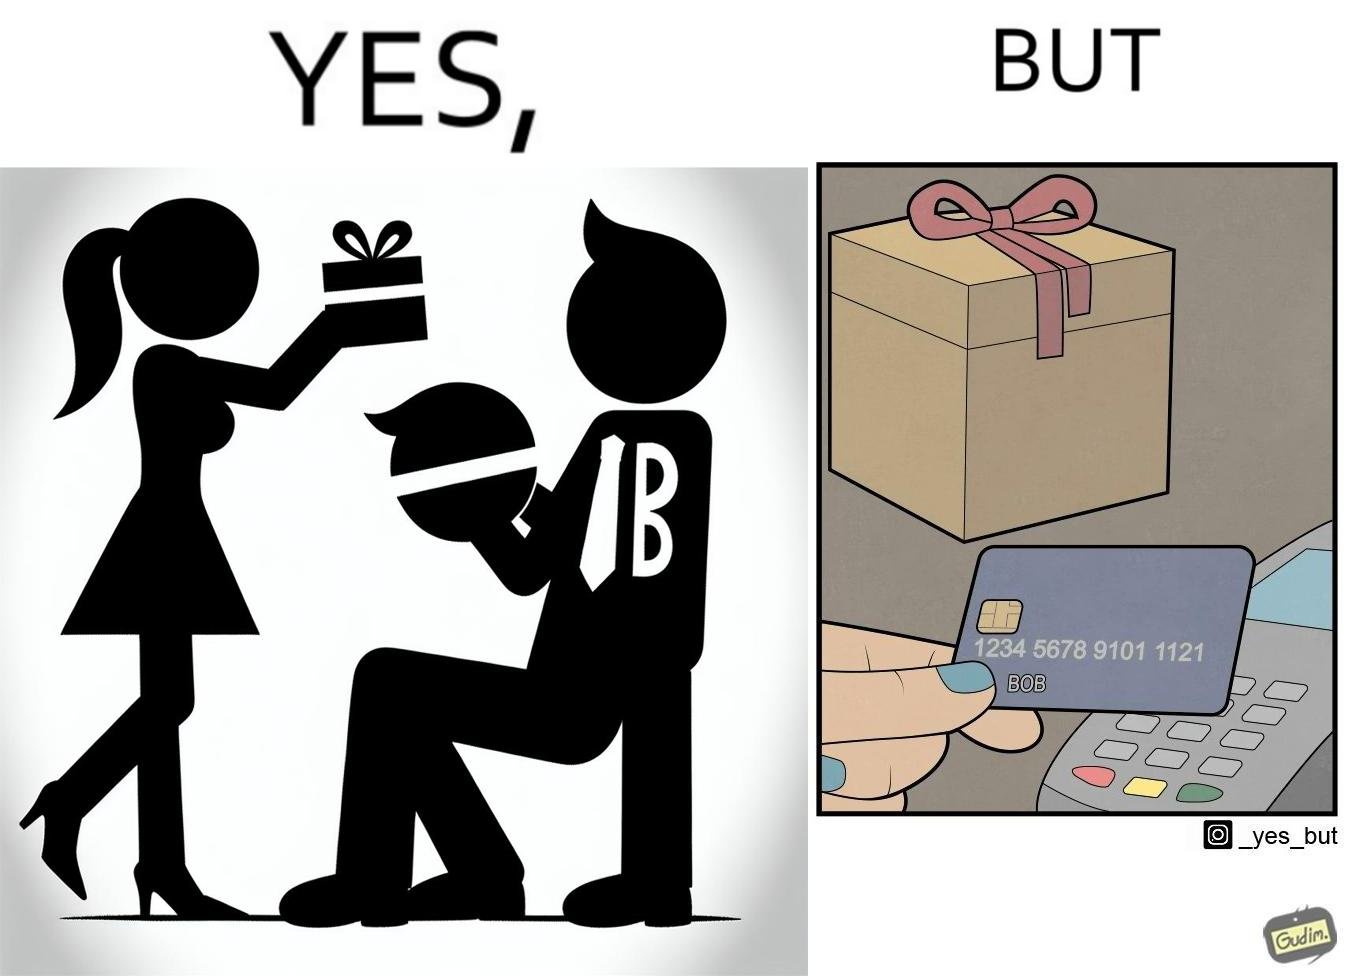Would you classify this image as satirical? Yes, this image is satirical. 